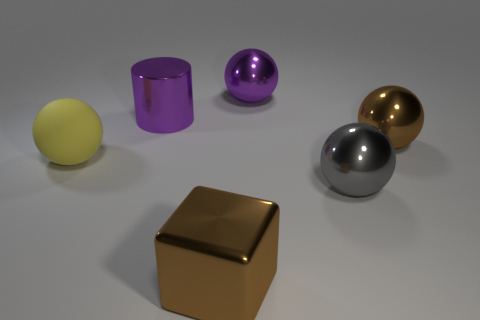Subtract all blue balls. Subtract all red blocks. How many balls are left? 4 Add 3 brown spheres. How many objects exist? 9 Subtract all balls. How many objects are left? 2 Subtract all large purple shiny spheres. Subtract all cubes. How many objects are left? 4 Add 1 brown shiny spheres. How many brown shiny spheres are left? 2 Add 2 yellow spheres. How many yellow spheres exist? 3 Subtract 0 yellow cylinders. How many objects are left? 6 